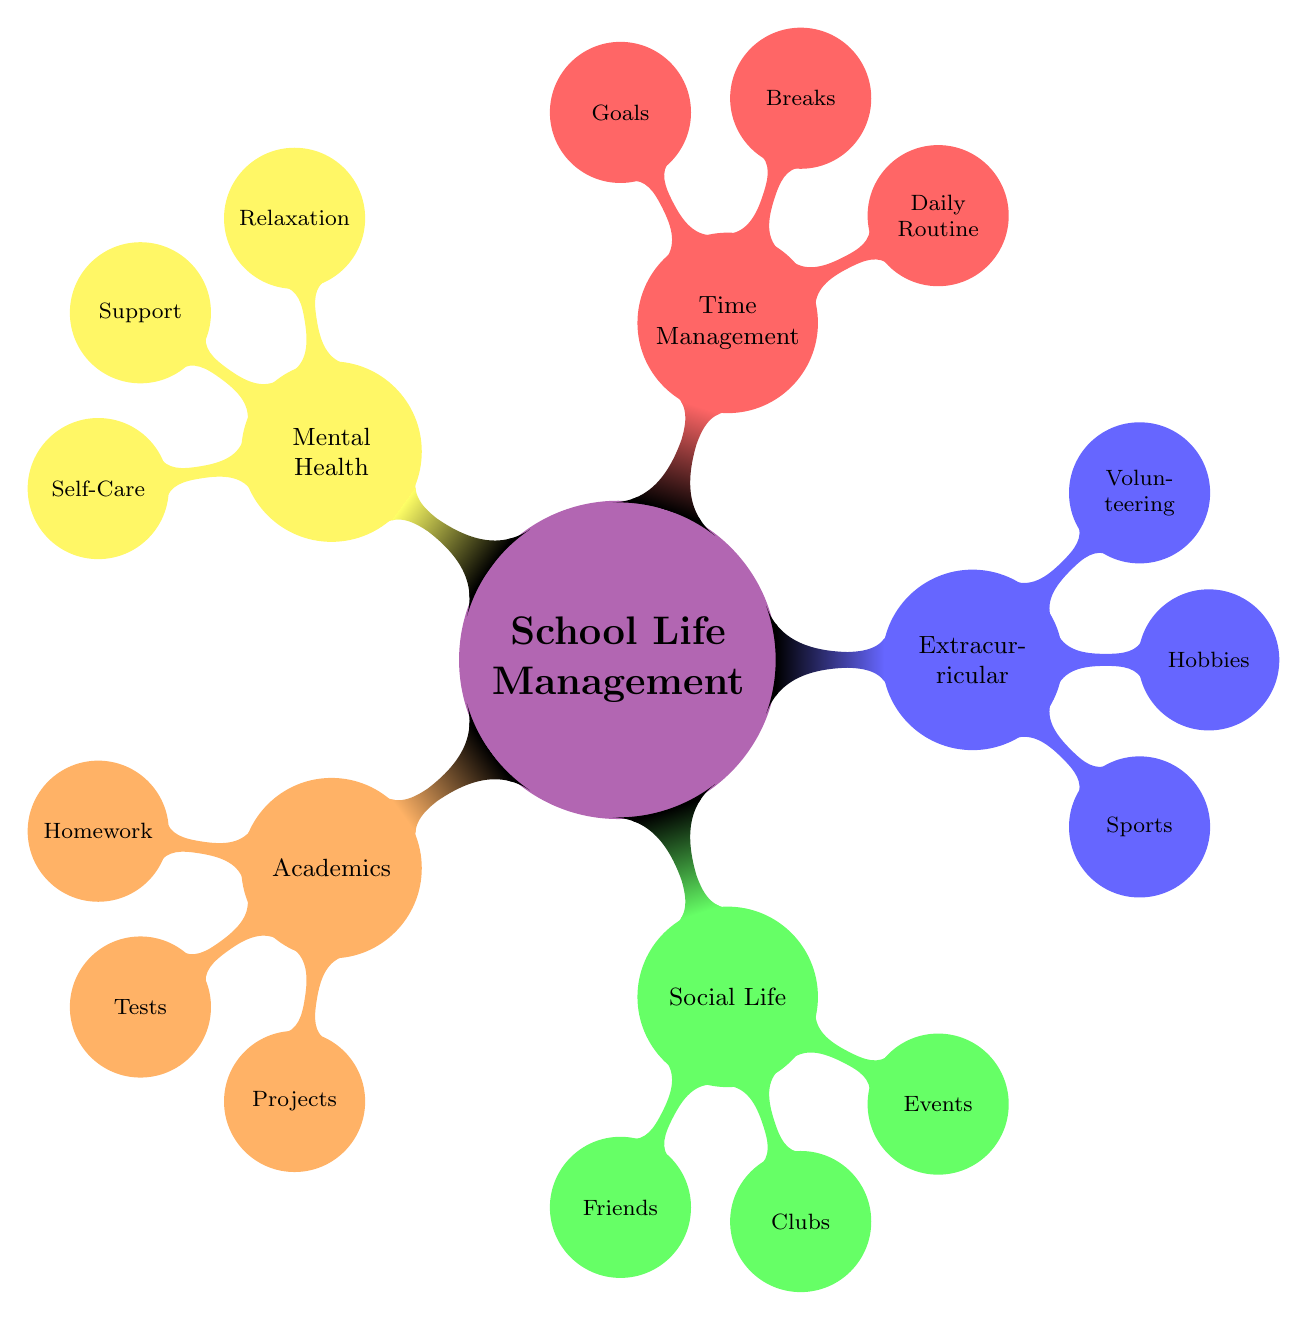What is the main topic of the mind map? The main topic is indicated at the center of the diagram, labeled as "School Life Management."
Answer: School Life Management How many main categories are there in the diagram? The main categories are the child nodes branching from the central node. There are five categories: Academics, Social Life, Extracurricular Activities, Time Management, and Mental Health.
Answer: 5 What is one activity listed under Academics? The activities listed under Academics can be found in its child nodes. One example is "Homework."
Answer: Homework Which extracurricular activity involves a team sport? The node under Extracurricular Activities labelled "Sports" indicates a team sport, as it commonly implies organized sports activities.
Answer: Sports What is one way to manage daily routines according to this diagram? The diagram suggests "Create a to-do list" under the Time Management category. This is a method to manage daily routines effectively.
Answer: Create a to-do list How are volunteering activities described in the diagram? Under Extracurricular Activities, the node labelled "Volunteering" refers to activities related to community service projects, showcasing a focus on helping others.
Answer: Community service projects Which category includes a method for mental well-being support? The "Mental Health" category includes "Support" where talking to a school counselor is recommended for mental well-being.
Answer: Support What are two examples of hobbies in the diagram? In the Extracurricular Activities category, one can find "Hobbies," which includes "Daily dance practice for TikTok" as a specific example.
Answer: Daily dance practice for TikTok What action should be taken during breaks according to the mind map? The Time Management category suggests "Schedule short study breaks," emphasizing the importance of break times during study sessions.
Answer: Schedule short study breaks How can friendship be fostered according to the diagram? Under the Social Life category, "Plan weekly hangouts" promotes fostering friendships through regular social interaction.
Answer: Plan weekly hangouts 